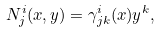<formula> <loc_0><loc_0><loc_500><loc_500>N ^ { i } _ { j } ( x , y ) = \gamma ^ { i } _ { j k } ( x ) y ^ { k } ,</formula> 